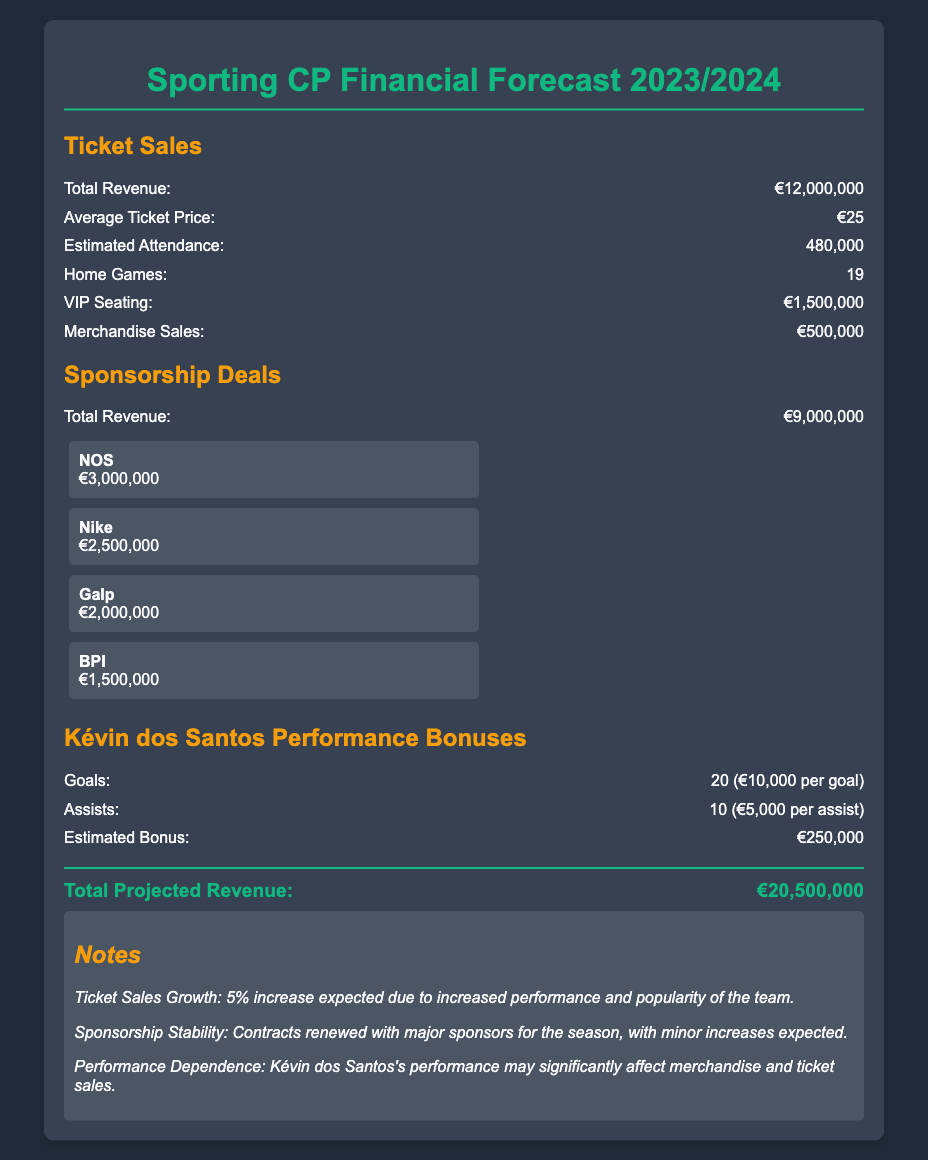What is the total projected revenue? The total projected revenue is calculated by summing the ticket sales, sponsorship deals, and performance bonuses, resulting in €20,500,000.
Answer: €20,500,000 What is the total revenue from ticket sales? The document specifies that the total revenue from ticket sales is €12,000,000.
Answer: €12,000,000 How many home games are projected for the season? The document lists the number of home games as 19.
Answer: 19 What is the estimated attendance? The estimated attendance figure mentioned in the document is 480,000.
Answer: 480,000 Who is the sponsor providing €3,000,000? The sponsor providing €3,000,000 is NOS.
Answer: NOS What is Kévin dos Santos’s estimated bonus? The document states that Kévin dos Santos's estimated bonus is €250,000 based on his performance.
Answer: €250,000 What is the average ticket price? The average ticket price mentioned in the document is €25.
Answer: €25 What growth in ticket sales is expected? The document notes a 5% increase is expected in ticket sales.
Answer: 5% What is the revenue from merchandise sales? The revenue from merchandise sales is listed as €500,000 in the document.
Answer: €500,000 